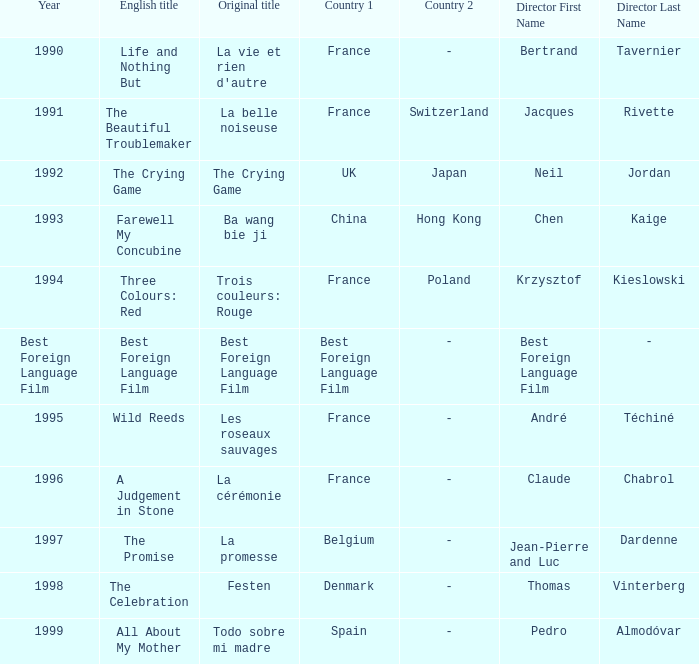Which Country has the Director Chen Kaige? China/Hong Kong. 